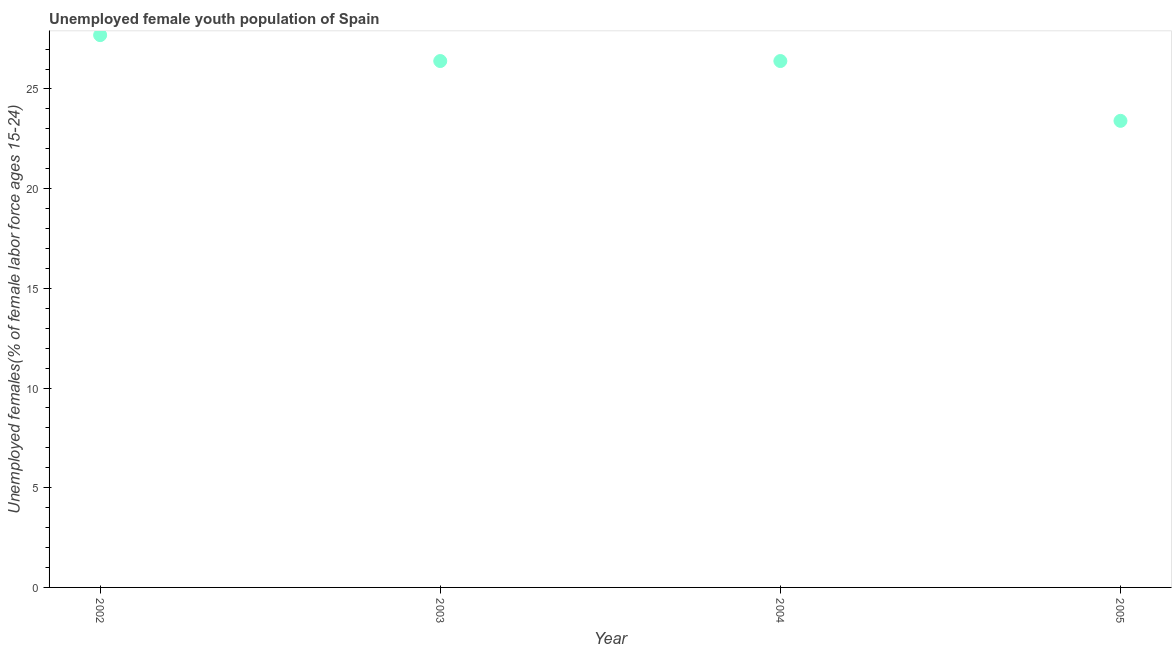What is the unemployed female youth in 2003?
Keep it short and to the point. 26.4. Across all years, what is the maximum unemployed female youth?
Your answer should be compact. 27.7. Across all years, what is the minimum unemployed female youth?
Give a very brief answer. 23.4. In which year was the unemployed female youth minimum?
Your response must be concise. 2005. What is the sum of the unemployed female youth?
Provide a short and direct response. 103.9. What is the difference between the unemployed female youth in 2002 and 2003?
Provide a succinct answer. 1.3. What is the average unemployed female youth per year?
Give a very brief answer. 25.97. What is the median unemployed female youth?
Make the answer very short. 26.4. What is the ratio of the unemployed female youth in 2002 to that in 2005?
Ensure brevity in your answer.  1.18. What is the difference between the highest and the second highest unemployed female youth?
Provide a short and direct response. 1.3. Is the sum of the unemployed female youth in 2003 and 2004 greater than the maximum unemployed female youth across all years?
Ensure brevity in your answer.  Yes. What is the difference between the highest and the lowest unemployed female youth?
Make the answer very short. 4.3. In how many years, is the unemployed female youth greater than the average unemployed female youth taken over all years?
Ensure brevity in your answer.  3. How many years are there in the graph?
Keep it short and to the point. 4. What is the difference between two consecutive major ticks on the Y-axis?
Your response must be concise. 5. Does the graph contain grids?
Provide a succinct answer. No. What is the title of the graph?
Your answer should be compact. Unemployed female youth population of Spain. What is the label or title of the X-axis?
Give a very brief answer. Year. What is the label or title of the Y-axis?
Give a very brief answer. Unemployed females(% of female labor force ages 15-24). What is the Unemployed females(% of female labor force ages 15-24) in 2002?
Your answer should be very brief. 27.7. What is the Unemployed females(% of female labor force ages 15-24) in 2003?
Make the answer very short. 26.4. What is the Unemployed females(% of female labor force ages 15-24) in 2004?
Keep it short and to the point. 26.4. What is the Unemployed females(% of female labor force ages 15-24) in 2005?
Your response must be concise. 23.4. What is the difference between the Unemployed females(% of female labor force ages 15-24) in 2002 and 2003?
Offer a terse response. 1.3. What is the difference between the Unemployed females(% of female labor force ages 15-24) in 2002 and 2005?
Offer a terse response. 4.3. What is the difference between the Unemployed females(% of female labor force ages 15-24) in 2003 and 2004?
Your response must be concise. 0. What is the difference between the Unemployed females(% of female labor force ages 15-24) in 2003 and 2005?
Your response must be concise. 3. What is the ratio of the Unemployed females(% of female labor force ages 15-24) in 2002 to that in 2003?
Provide a succinct answer. 1.05. What is the ratio of the Unemployed females(% of female labor force ages 15-24) in 2002 to that in 2004?
Provide a short and direct response. 1.05. What is the ratio of the Unemployed females(% of female labor force ages 15-24) in 2002 to that in 2005?
Ensure brevity in your answer.  1.18. What is the ratio of the Unemployed females(% of female labor force ages 15-24) in 2003 to that in 2005?
Provide a succinct answer. 1.13. What is the ratio of the Unemployed females(% of female labor force ages 15-24) in 2004 to that in 2005?
Offer a very short reply. 1.13. 